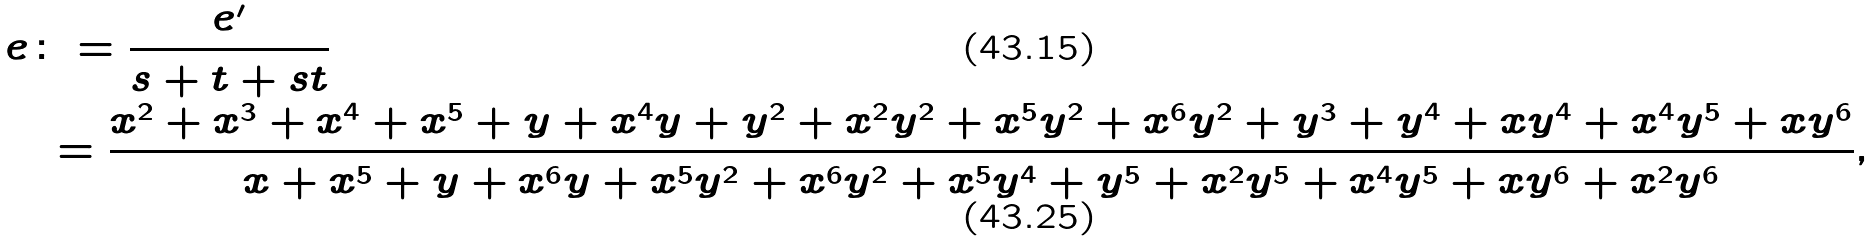<formula> <loc_0><loc_0><loc_500><loc_500>e & \colon = \frac { e ^ { \prime } } { s + t + s t } \\ & \ = \frac { x ^ { 2 } + x ^ { 3 } + x ^ { 4 } + x ^ { 5 } + y + x ^ { 4 } y + y ^ { 2 } + x ^ { 2 } y ^ { 2 } + x ^ { 5 } y ^ { 2 } + x ^ { 6 } y ^ { 2 } + y ^ { 3 } + y ^ { 4 } + x y ^ { 4 } + x ^ { 4 } y ^ { 5 } + x y ^ { 6 } } { x + x ^ { 5 } + y + x ^ { 6 } y + x ^ { 5 } y ^ { 2 } + x ^ { 6 } y ^ { 2 } + x ^ { 5 } y ^ { 4 } + y ^ { 5 } + x ^ { 2 } y ^ { 5 } + x ^ { 4 } y ^ { 5 } + x y ^ { 6 } + x ^ { 2 } y ^ { 6 } } ,</formula> 